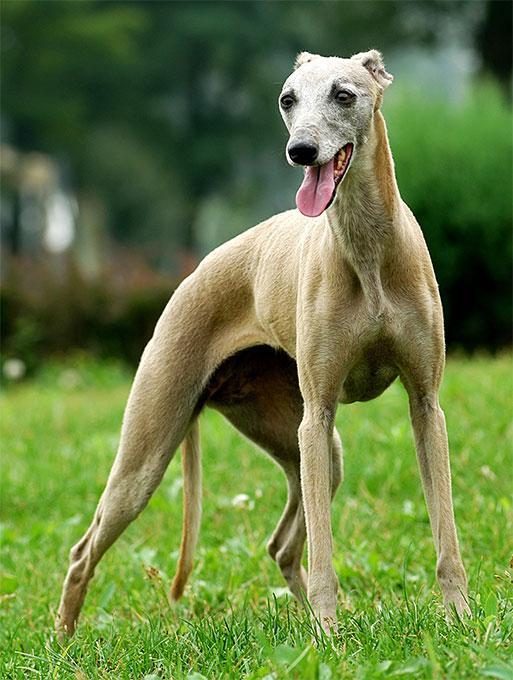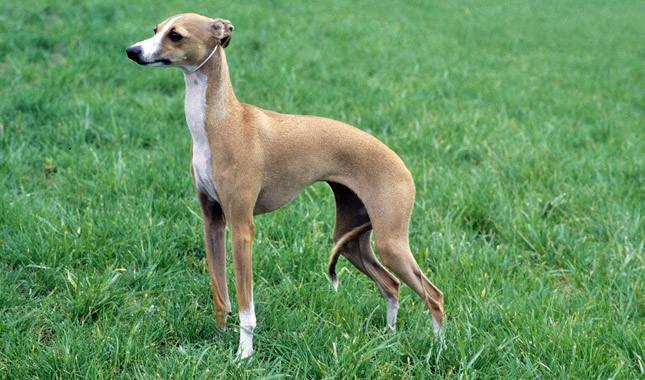The first image is the image on the left, the second image is the image on the right. For the images shown, is this caption "The dog in the right image wears a collar." true? Answer yes or no. No. 